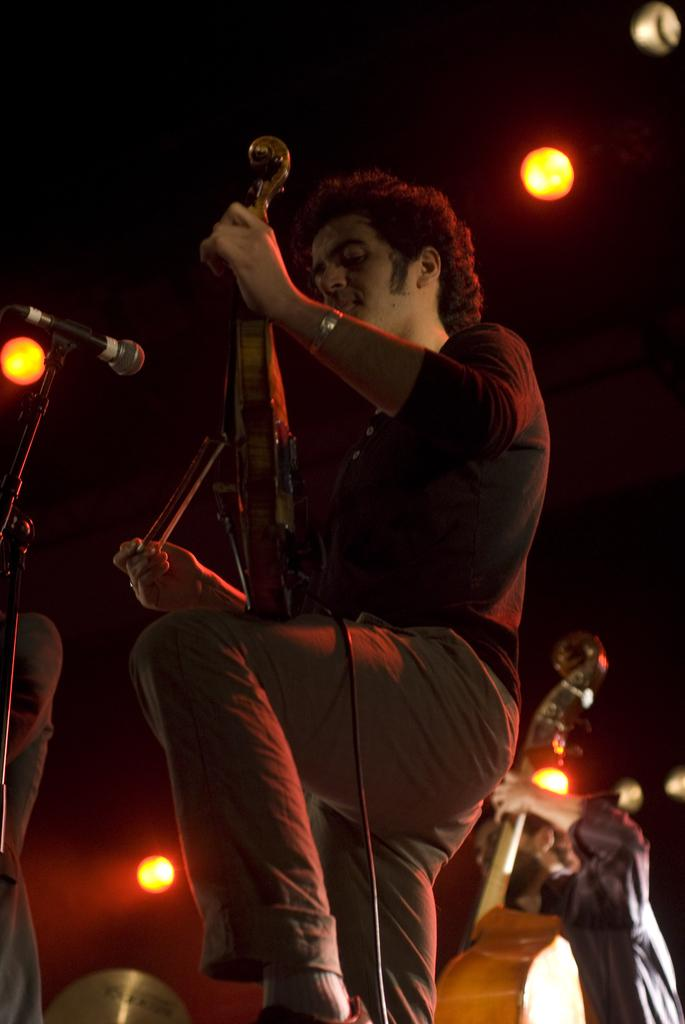What is the man in the image wearing? The man in the image is wearing a black shirt and brown pants. What is the man doing in the image? The man is playing a violin. What is in front of the man? There is a microphone in front of the man. Are there any other musicians in the image? Yes, there is another man in the image playing a violin. What can be seen on the ceiling in the image? There are lights on the ceiling. What type of prison is depicted in the image? There is no prison present in the image; it features two men playing violins with a microphone and lights. How does the birth of a newborn relate to the image? The image does not depict a birth or any related events; it focuses on two men playing violins. 